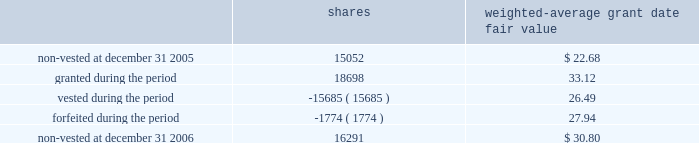O 2019 r e i l l y a u t o m o t i v e 2 0 0 6 a n n u a l r e p o r t p a g e 38 $ 11080000 , in the years ended december 31 , 2006 , 2005 and 2004 , respectively .
The remaining unrecognized compensation cost related to unvested awards at december 31 , 2006 , was $ 7702000 and the weighted-average period of time over which this cost will be recognized is 3.3 years .
Employee stock purchase plan the company 2019s employee stock purchase plan permits all eligible employees to purchase shares of the company 2019s common stock at 85% ( 85 % ) of the fair market value .
Participants may authorize the company to withhold up to 5% ( 5 % ) of their annual salary to participate in the plan .
The stock purchase plan authorizes up to 2600000 shares to be granted .
During the year ended december 31 , 2006 , the company issued 165306 shares under the purchase plan at a weighted average price of $ 27.36 per share .
During the year ended december 31 , 2005 , the company issued 161903 shares under the purchase plan at a weighted average price of $ 27.57 per share .
During the year ended december 31 , 2004 , the company issued 187754 shares under the purchase plan at a weighted average price of $ 20.85 per share .
Sfas no .
123r requires compensation expense to be recognized based on the discount between the grant date fair value and the employee purchase price for shares sold to employees .
During the year ended december 31 , 2006 , the company recorded $ 799000 of compensation cost related to employee share purchases and a corresponding income tax benefit of $ 295000 .
At december 31 , 2006 , approximately 400000 shares were reserved for future issuance .
Other employee benefit plans the company sponsors a contributory profit sharing and savings plan that covers substantially all employees who are at least 21 years of age and have at least six months of service .
The company has agreed to make matching contributions equal to 50% ( 50 % ) of the first 2% ( 2 % ) of each employee 2019s wages that are contributed and 25% ( 25 % ) of the next 4% ( 4 % ) of each employee 2019s wages that are contributed .
The company also makes additional discretionary profit sharing contributions to the plan on an annual basis as determined by the board of directors .
The company 2019s matching and profit sharing contributions under this plan are funded in the form of shares of the company 2019s common stock .
A total of 4200000 shares of common stock have been authorized for issuance under this plan .
During the year ended december 31 , 2006 , the company recorded $ 6429000 of compensation cost for contributions to this plan and a corresponding income tax benefit of $ 2372000 .
During the year ended december 31 , 2005 , the company recorded $ 6606000 of compensation cost for contributions to this plan and a corresponding income tax benefit of $ 2444000 .
During the year ended december 31 , 2004 , the company recorded $ 5278000 of compensation cost for contributions to this plan and a corresponding income tax benefit of $ 1969000 .
The compensation cost recorded in 2006 includes matching contributions made in 2006 and profit sharing contributions accrued in 2006 to be funded with issuance of shares of common stock in 2007 .
The company issued 204000 shares in 2006 to fund profit sharing and matching contributions at an average grant date fair value of $ 34.34 .
The company issued 210461 shares in 2005 to fund profit sharing and matching contributions at an average grant date fair value of $ 25.79 .
The company issued 238828 shares in 2004 to fund profit sharing and matching contributions at an average grant date fair value of $ 19.36 .
A portion of these shares related to profit sharing contributions accrued in prior periods .
At december 31 , 2006 , approximately 1061000 shares were reserved for future issuance under this plan .
The company has in effect a performance incentive plan for the company 2019s senior management under which the company awards shares of restricted stock that vest equally over a three-year period and are held in escrow until such vesting has occurred .
Shares are forfeited when an employee ceases employment .
A total of 800000 shares of common stock have been authorized for issuance under this plan .
Shares awarded under this plan are valued based on the market price of the company 2019s common stock on the date of grant and compensation cost is recorded over the vesting period .
The company recorded $ 416000 of compensation cost for this plan for the year ended december 31 , 2006 and recognized a corresponding income tax benefit of $ 154000 .
The company recorded $ 289000 of compensation cost for this plan for the year ended december 31 , 2005 and recognized a corresponding income tax benefit of $ 107000 .
The company recorded $ 248000 of compensation cost for this plan for the year ended december 31 , 2004 and recognized a corresponding income tax benefit of $ 93000 .
The total fair value of shares vested ( at vest date ) for the years ended december 31 , 2006 , 2005 and 2004 were $ 503000 , $ 524000 and $ 335000 , respectively .
The remaining unrecognized compensation cost related to unvested awards at december 31 , 2006 was $ 536000 .
The company awarded 18698 shares under this plan in 2006 with an average grant date fair value of $ 33.12 .
The company awarded 14986 shares under this plan in 2005 with an average grant date fair value of $ 25.41 .
The company awarded 15834 shares under this plan in 2004 with an average grant date fair value of $ 19.05 .
Compensation cost for shares awarded in 2006 will be recognized over the three-year vesting period .
Changes in the company 2019s restricted stock for the year ended december 31 , 2006 were as follows : weighted- average grant date shares fair value .
At december 31 , 2006 , approximately 659000 shares were reserved for future issuance under this plan .
N o t e s t o c o n s o l i d a t e d f i n a n c i a l s t a t e m e n t s ( cont inued ) .
What is the amount of cash raised from the issuance of shares during 2015 , in millions? 
Computations: ((161903 * 27.57) / 1000000)
Answer: 4.46367. 